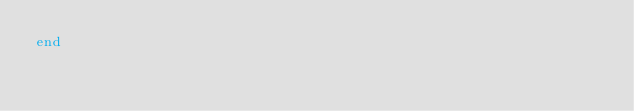<code> <loc_0><loc_0><loc_500><loc_500><_Ruby_>end

</code> 